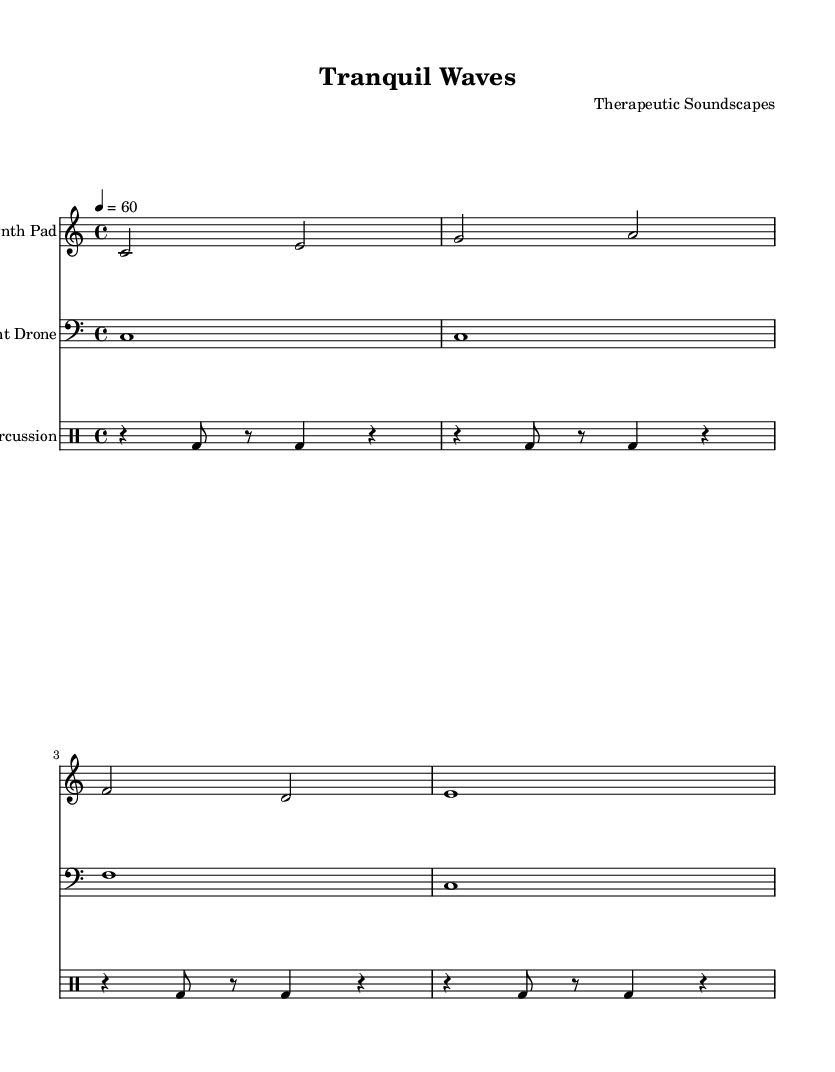What is the key signature of this music? The key signature is C major, which is indicated at the beginning of the score and has no sharps or flats.
Answer: C major What is the time signature of this piece? The time signature appears in the score and is indicated right after the key signature, showing 4 beats per measure.
Answer: 4/4 What is the tempo marking for the composition? The tempo marking is found in the header section, specifying the beat rate of 60 beats per minute.
Answer: 60 How many measures are in the Synth Pad staff? By counting the distinct sets of vertical lines in the Synth Pad staff, we find there are four measures.
Answer: 4 What type of sound sources are primarily used in this piece? Analyzing the instrumentation provided, this piece involves synthesizers (Synth Pad and Ambient Drone) and drum sounds (Soft Percussion).
Answer: Synthesizers and drums Explain the rhythmic pattern used in the Soft Percussion. The first measure of the Soft Percussion indicates a sequence of rests and bass drum hits. It follows a repeating pattern that can be analyzed as comprised of alternating resting and active beats organized in eighth and quarter notes.
Answer: Rests and bass drum hits 